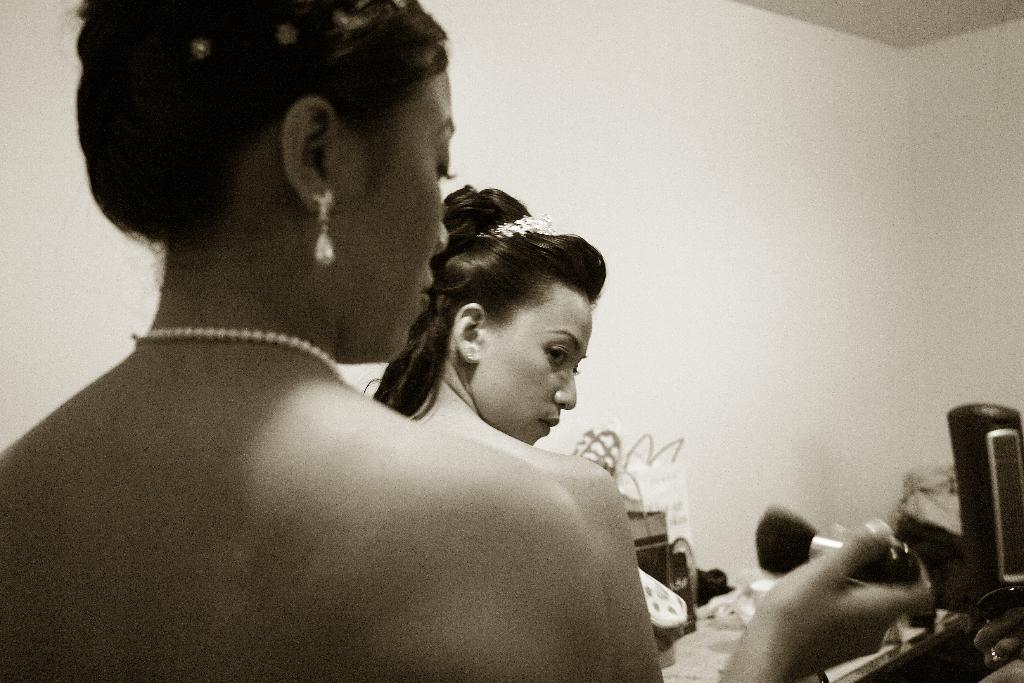What is the color scheme of the image? The image is black and white. How many people are in the image? There are two persons in the image. What is one person holding in the image? One person is holding a makeup brush. What can be seen in the image besides the people? There are bags and other objects in the image. What is visible in the background of the image? There is a wall in the background of the image. What type of bread is the farmer holding in the image? There is no bread or farmer present in the image. How much payment is being exchanged between the two persons in the image? There is no indication of any payment being exchanged between the two persons in the image. 